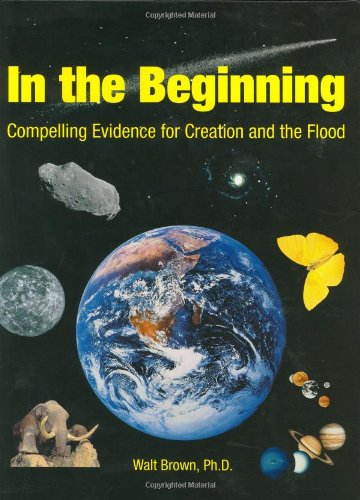Is this a romantic book? No, this book is not a romance novel; it focuses instead on religious and creationist theories concerning the origins of the Earth and humanity. 